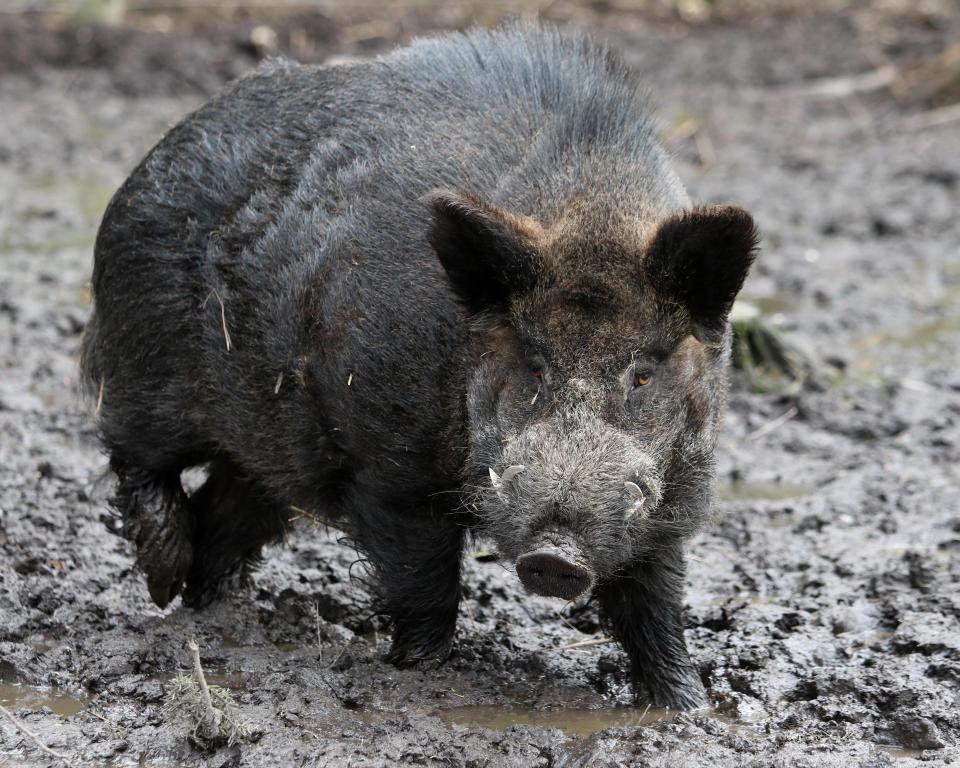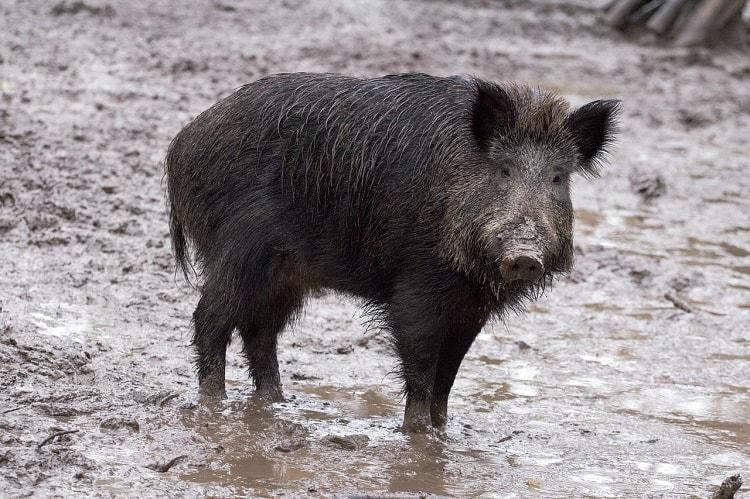The first image is the image on the left, the second image is the image on the right. Examine the images to the left and right. Is the description "The one boar in the left image is facing more toward the camera than the boar in the right image." accurate? Answer yes or no. Yes. The first image is the image on the left, the second image is the image on the right. Analyze the images presented: Is the assertion "There are at least two animals in one of the images." valid? Answer yes or no. No. 